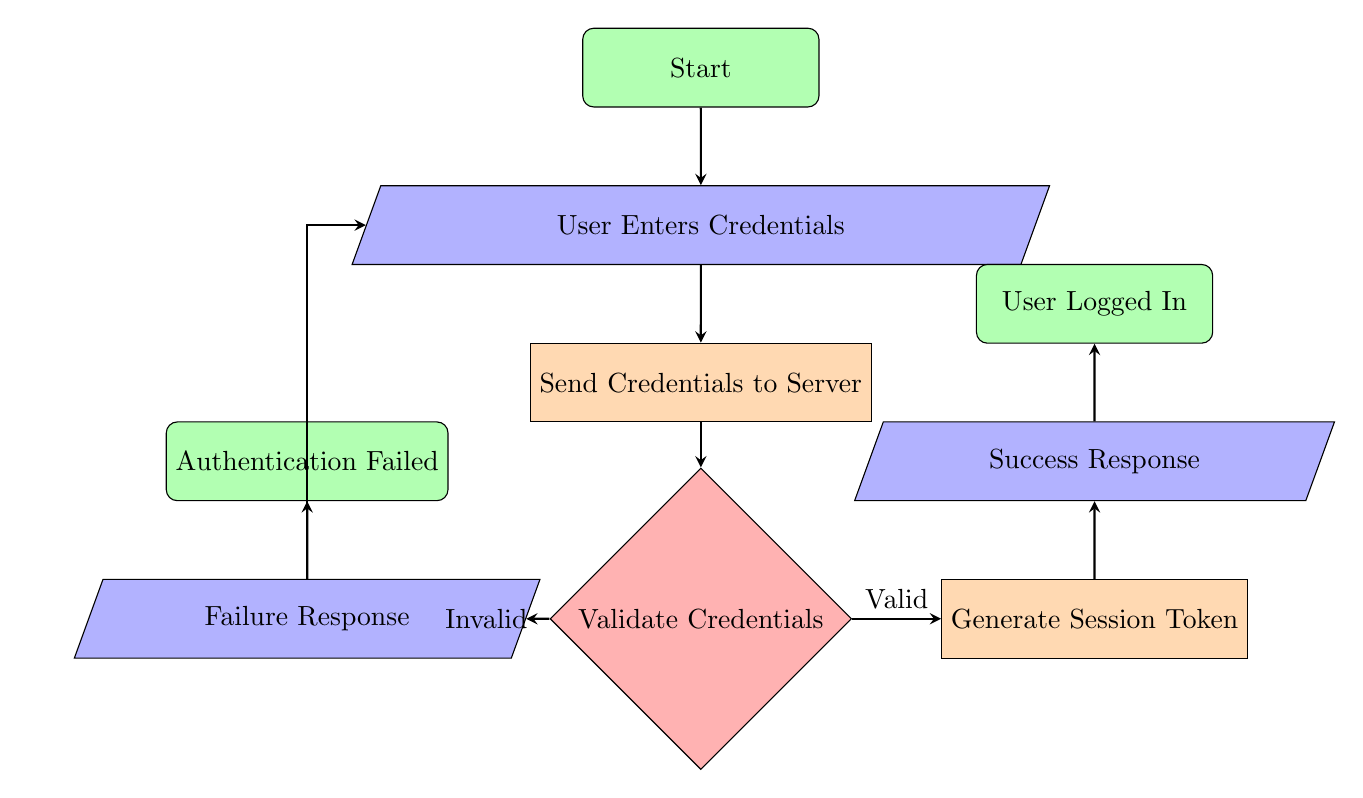What is the first step in the user login authentication process? The first step is represented by the start node, which indicates the beginning of the user login authentication process.
Answer: Start What happens after the user enters their credentials? After entering credentials, the next step in the flow is that the client's device sends the entered credentials to the authentication server.
Answer: Send Credentials to Server What does the server do after receiving the credentials? The server checks the provided username and password against the stored credentials to validate them.
Answer: Validate Credentials What is the outcome if the credentials are valid? If the credentials are valid, the server generates a session token, allowing the user to be logged into the application successfully.
Answer: Generate Session Token How many output responses are there in the flow chart? There are two output responses: Success Response and Failure Response.
Answer: 2 What does the flow do if the credentials are invalid? If the credentials are invalid, the flow leads to the Failure Response node, indicating that an error message is sent back to the client.
Answer: Failure Response What is the end result if the user successfully logs in? The end result when the user successfully logs in is that they are granted access to the application.
Answer: User Logged In What leads to the Authentication Failed step? The Authentication Failed step is reached if the user is prompted to re-enter credentials or utilize the password recovery process after receiving a failure response.
Answer: Failure Response What kind of node is used to represent the decision point in the flow? The decision point in the flow is represented by a diamond-shaped node, which indicates a validation decision regarding credentials.
Answer: Decision What is the last action taken in the process if authentication is successful? The last action taken is sending a success response with the session token back to the client after generating it.
Answer: Success Response 